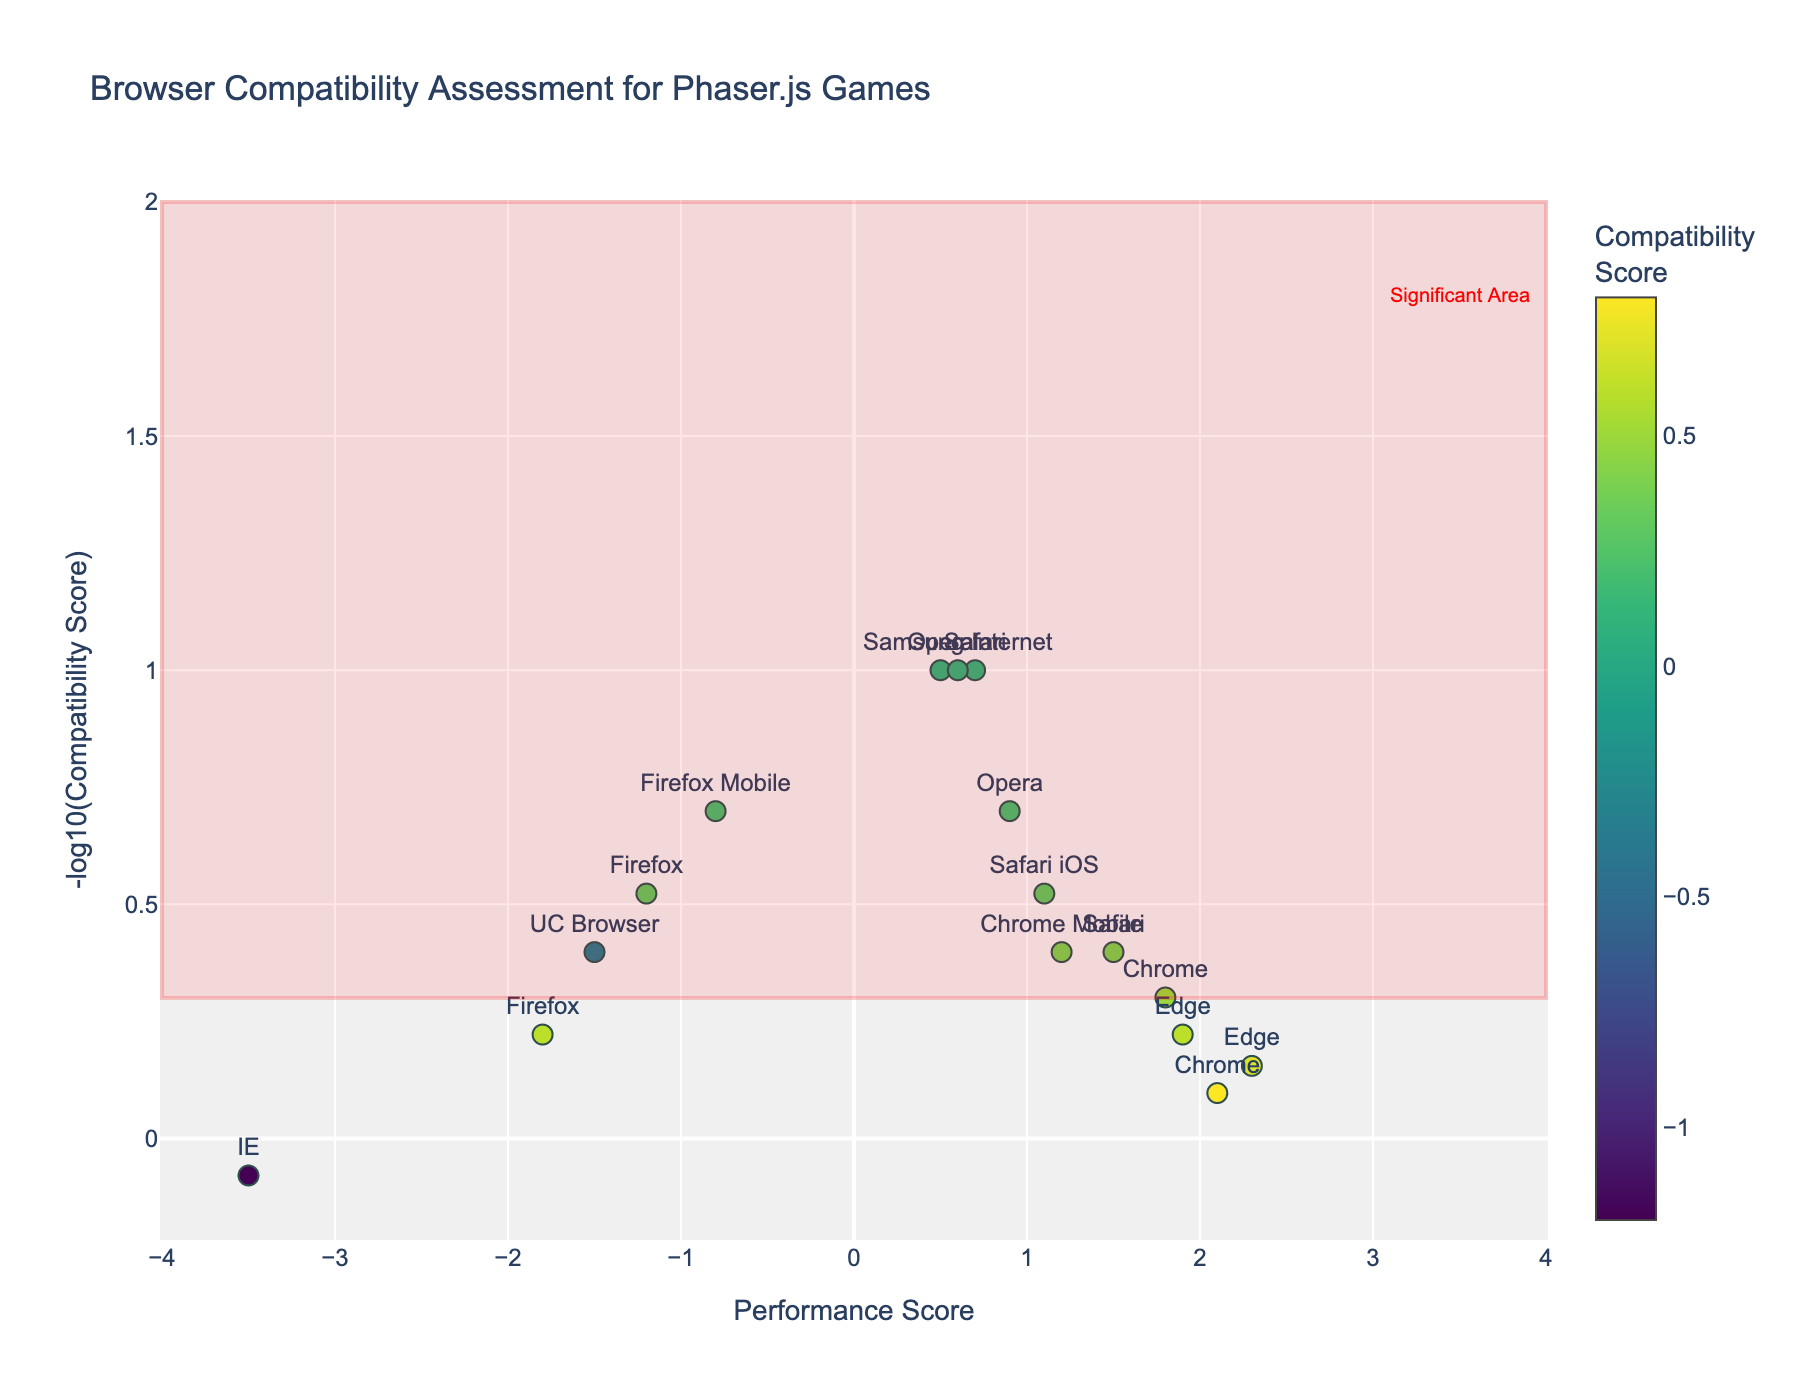What is the title of the plot? The title of the plot is found at the top of the figure.
Answer: Browser Compatibility Assessment for Phaser.js Games Which browser and version have the lowest Performance Score? The browser with the lowest Performance Score is found by locating the point furthest to the left on the x-axis.
Answer: IE 11 Which browser and version have the highest Compatibility Score? The browser with the highest Compatibility Score is found by looking at the color bar and finding the darkest green point in the figure.
Answer: Edge 96 What does the shape highlighted in red represent? The highlighted shape and annotation in the plot can be found in the upper right area of the plot.
Answer: Significant Area How many browsers score above 0 in Performance Score? Count the number of points that are positioned to the right of the y-axis on the plot.
Answer: 11 Compare Chrome 96 and Firefox 94, which one has a higher Compatibility Score? Compare the color (shade of green) of the points representing Chrome 96 and Firefox 94. Darker green indicates a higher Compatibility Score.
Answer: Chrome 96 Which browser version has the closest to zero Compatibility Score? Find the point closest to the baseline on the color bar, which signifies a Compatibility Score of zero.
Answer: Safari 14 and Opera 79 What is the typical compatibility level trend seen in mobile browsers compared to desktop browsers? Compare the position and color of the data points representing mobile browsers (labeled "Mobile" or iOS) with those of desktop browsers.
Answer: Typically lower Compatibility Scores How does the Performance Score of Chrome versions compare across different releases? Analyze the positions of all points labeled as "Chrome" on the x-axis to compare their Performance Scores.
Answer: Generally, high and positive Which browser version, Chrome or Edge 96, has a better overall balance between Performance and Compatibility Scores? Look at both the horizontal and vertical positions of the points for Chrome 96 and Edge 96 on the volcano plot; both should be high up and far to the right for better balance.
Answer: Edge 96 